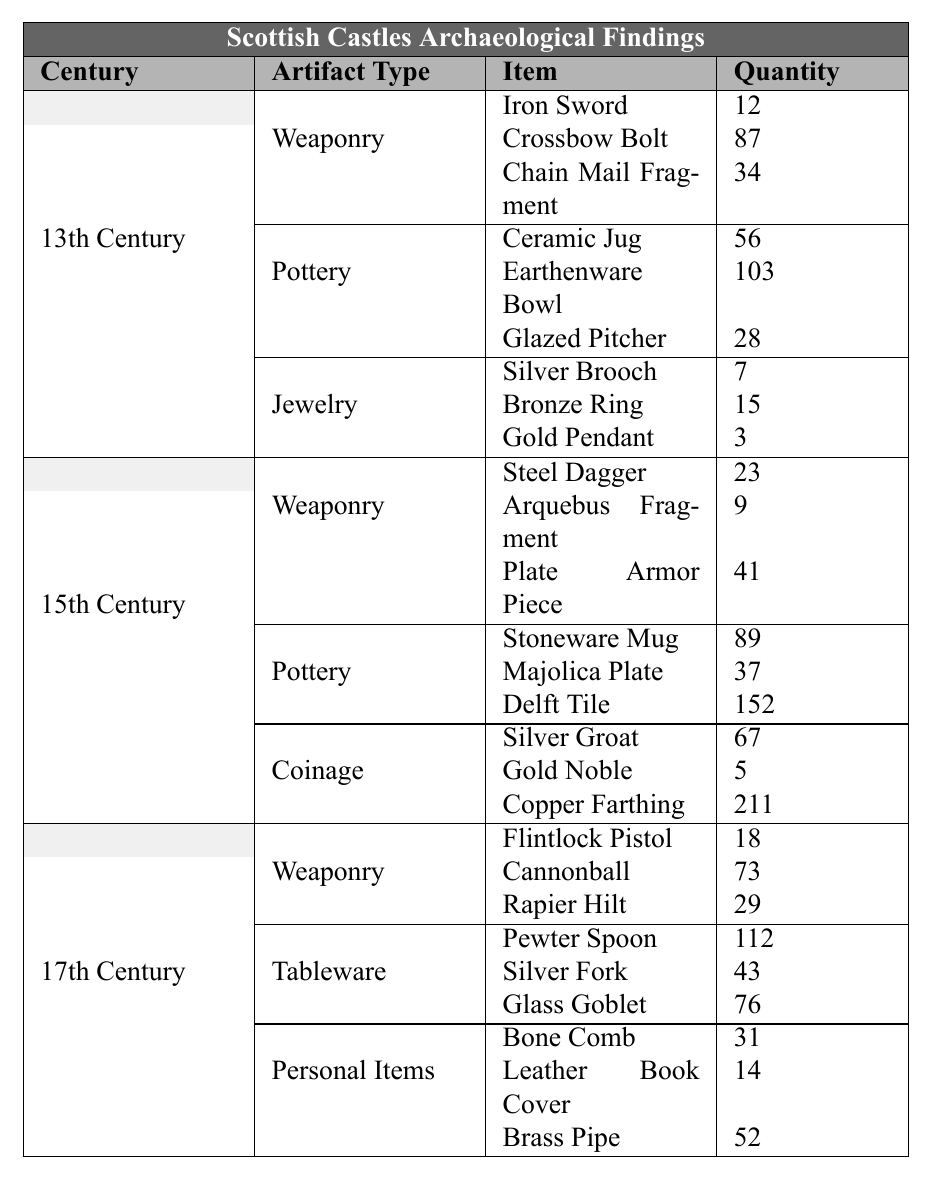What is the total number of weaponry artifacts from the 15th century? The weaponry artifacts from the 15th century include a Steel Dagger (23), Arquebus Fragment (9), and Plate Armor Piece (41). Adding these values together gives 23 + 9 + 41 = 73.
Answer: 73 Which artifact type had the highest quantity in the 17th century? In the 17th century, the artifacts were divided into Weaponry, Tableware, and Personal Items. The Tableware contains the highest quantity of items, with 112 Pewter Spoons, 43 Silver Forks, and 76 Glass Goblets, totaling 112 + 43 + 76 = 231, which is more than the totals for Weaponry (120) and Personal Items (97).
Answer: Tableware Is there any jewelry found in the 15th century? The table does not list any jewelry artifacts in the 15th century as it only includes weaponry, pottery, and coinage. Thus, the statement is false.
Answer: No What is the average quantity of pottery artifacts found in the 13th century? The pottery artifacts include a Ceramic Jug (56), Earthenware Bowl (103), and Glazed Pitcher (28). The total quantity is 56 + 103 + 28 = 187. To find the average, this total is divided by the number of pottery items, which is 3, giving an average of 187 / 3 = 62.33.
Answer: 62.33 Which century had the largest number of artifacts overall? To find the overall count, we sum the quantities across all artifact types for each century. 13th Century: 12+87+34+56+103+28+7+15+3 = 315, 15th Century: 23+9+41+89+37+152+67+5+211 = 633, and 17th Century: 18+73+29+112+43+76+31+14+52 = 406. The largest total is for the 15th century with 633 artifacts.
Answer: 15th Century How many more pottery items were found in the 15th century compared to the 13th century? The 15th century pottery has a total of 89 (Stoneware Mug) + 37 (Majolica Plate) + 152 (Delft Tile) = 278. The 13th century pottery total is 56 + 103 + 28 = 187. The difference is 278 - 187 = 91.
Answer: 91 Are there more items in weaponry or personal items in the 17th century? In the 17th century, weaponry totals 18 (Flintlock Pistol) + 73 (Cannonball) + 29 (Rapier Hilt) = 120, while personal items total 31 (Bone Comb) + 14 (Leather Book Cover) + 52 (Brass Pipe) = 97. Since 120 > 97, weaponry has more items.
Answer: Yes, weaponry What is the total quantity of all artifacts found in the 13th century? Summing all the artifacts for the 13th century gives us 12 (Weaponry) + 87 + 34 + 56 (Pottery) + 103 + 28 + 7 (Jewelry) + 15 + 3 = 315. Thus, the total quantity of artifacts is 315.
Answer: 315 